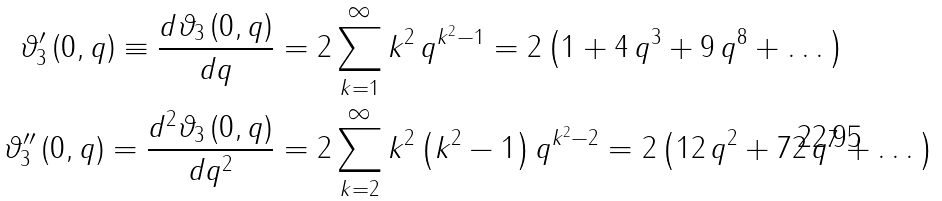<formula> <loc_0><loc_0><loc_500><loc_500>\vartheta _ { 3 } ^ { \prime } \left ( 0 , q \right ) \equiv \frac { d \vartheta _ { 3 } \left ( 0 , q \right ) } { d q } & = 2 \sum _ { k = 1 } ^ { \infty } k ^ { 2 } \, q ^ { k ^ { 2 } - 1 } = 2 \left ( 1 + 4 \, q ^ { 3 } + 9 \, q ^ { 8 } + \dots \right ) \\ \vartheta _ { 3 } ^ { \prime \prime } \left ( 0 , q \right ) = \frac { d ^ { 2 } \vartheta _ { 3 } \left ( 0 , q \right ) } { d q ^ { 2 } } & = 2 \sum _ { k = 2 } ^ { \infty } k ^ { 2 } \left ( k ^ { 2 } - 1 \right ) q ^ { k ^ { 2 } - 2 } = 2 \left ( 1 2 \, q ^ { 2 } + 7 2 \, q ^ { 7 } + \dots \right )</formula> 